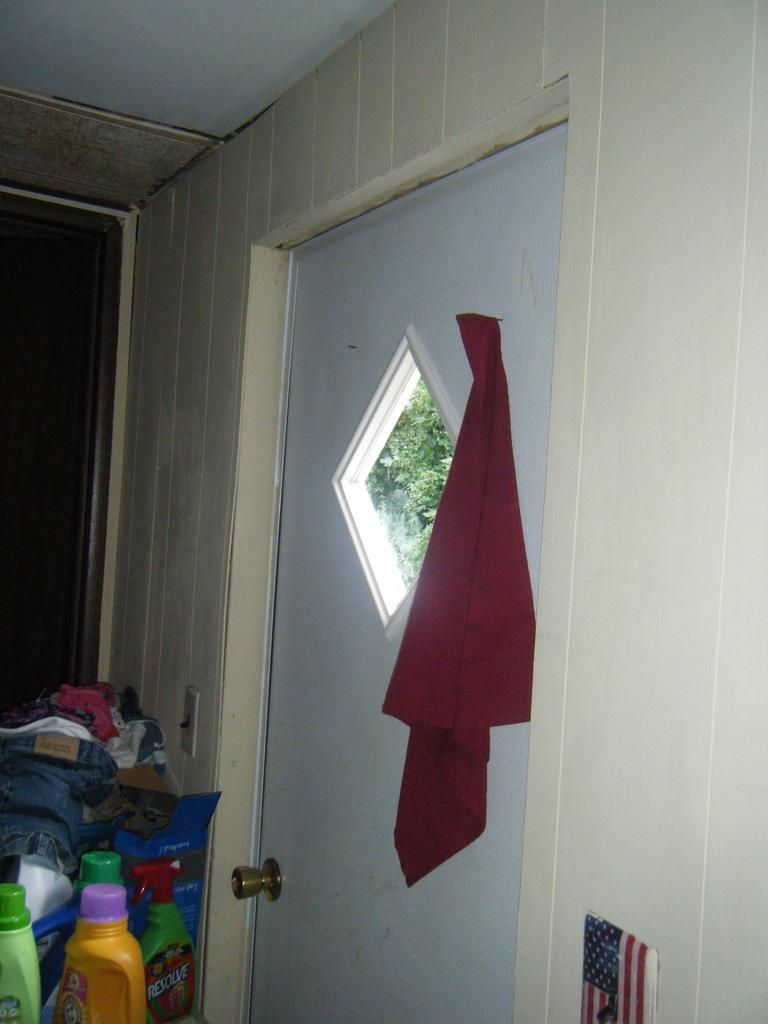What type of door is in the image? There is a white door in the image. What feature is present on the door? The door has a door handle. What is hanging on the door? There is a red cloth hanging on the door. What can be seen in the image besides the door? There are bottles, clothes, and other objects visible in the image. What is visible through the door? A tree is visible through the door. Can you tell me who is winning the argument in the image? There is no argument present in the image; it features a white door with a door handle, a red cloth hanging on it, and other objects visible in the room. What type of sack is being used to carry the clothes in the image? There is no sack present in the image; the clothes are simply visible among the other objects. 